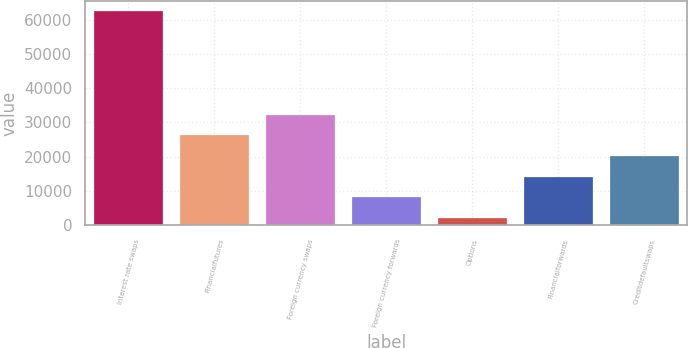<chart> <loc_0><loc_0><loc_500><loc_500><bar_chart><fcel>Interest rate swaps<fcel>Financialfutures<fcel>Foreign currency swaps<fcel>Foreign currency forwards<fcel>Options<fcel>Financialforwards<fcel>Creditdefaultswaps<nl><fcel>62519<fcel>26233.4<fcel>32281<fcel>8090.6<fcel>2043<fcel>14138.2<fcel>20185.8<nl></chart> 